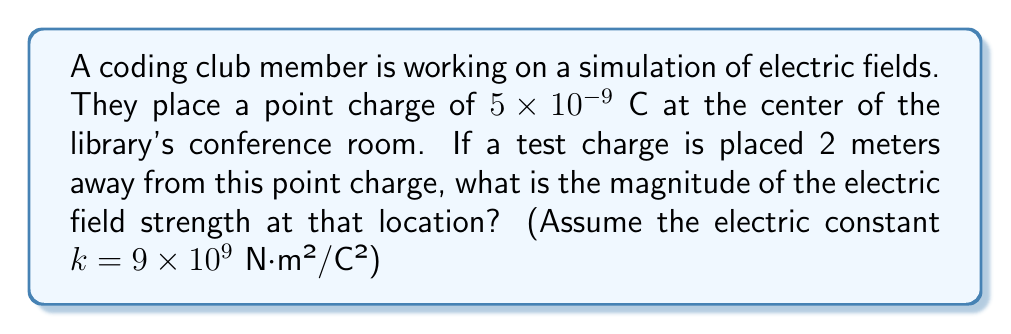Solve this math problem. To solve this problem, we'll use Coulomb's law for the electric field strength due to a point charge:

$$E = k \frac{|q|}{r^2}$$

Where:
$E$ is the electric field strength
$k$ is the electric constant ($9 \times 10^9$ N⋅m²/C²)
$|q|$ is the absolute value of the charge
$r$ is the distance from the charge

Step 1: Identify the given values
$k = 9 \times 10^9$ N⋅m²/C²
$|q| = 5 \times 10^{-9}$ C
$r = 2$ m

Step 2: Substitute these values into the equation
$$E = (9 \times 10^9) \frac{5 \times 10^{-9}}{2^2}$$

Step 3: Simplify
$$E = (9 \times 10^9) \frac{5 \times 10^{-9}}{4}$$
$$E = \frac{45 \times 10^0}{4} = 11.25$$

Step 4: Add the units (N/C)

The final answer is 11.25 N/C.
Answer: 11.25 N/C 